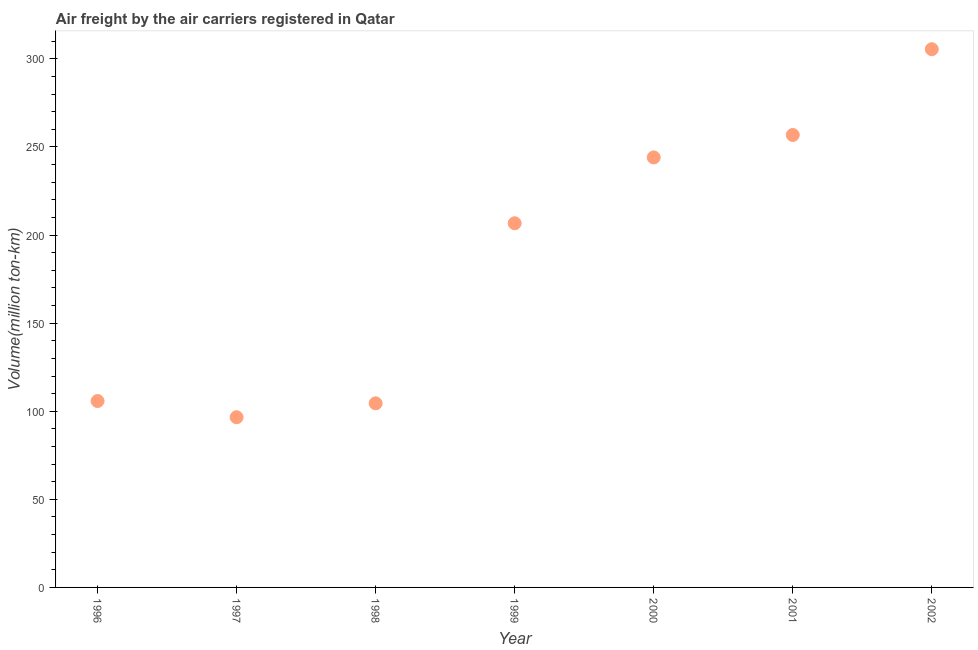What is the air freight in 1999?
Your answer should be very brief. 206.7. Across all years, what is the maximum air freight?
Make the answer very short. 305.48. Across all years, what is the minimum air freight?
Ensure brevity in your answer.  96.6. In which year was the air freight minimum?
Offer a very short reply. 1997. What is the sum of the air freight?
Offer a terse response. 1319.97. What is the difference between the air freight in 1998 and 2002?
Your response must be concise. -200.98. What is the average air freight per year?
Ensure brevity in your answer.  188.57. What is the median air freight?
Provide a succinct answer. 206.7. Do a majority of the years between 2001 and 1996 (inclusive) have air freight greater than 280 million ton-km?
Provide a short and direct response. Yes. What is the ratio of the air freight in 1997 to that in 2002?
Offer a very short reply. 0.32. What is the difference between the highest and the second highest air freight?
Offer a terse response. 48.67. What is the difference between the highest and the lowest air freight?
Provide a short and direct response. 208.88. How many dotlines are there?
Your answer should be very brief. 1. Are the values on the major ticks of Y-axis written in scientific E-notation?
Give a very brief answer. No. Does the graph contain any zero values?
Offer a terse response. No. What is the title of the graph?
Your answer should be very brief. Air freight by the air carriers registered in Qatar. What is the label or title of the Y-axis?
Provide a succinct answer. Volume(million ton-km). What is the Volume(million ton-km) in 1996?
Your response must be concise. 105.8. What is the Volume(million ton-km) in 1997?
Provide a short and direct response. 96.6. What is the Volume(million ton-km) in 1998?
Your response must be concise. 104.5. What is the Volume(million ton-km) in 1999?
Provide a short and direct response. 206.7. What is the Volume(million ton-km) in 2000?
Offer a very short reply. 244.07. What is the Volume(million ton-km) in 2001?
Provide a succinct answer. 256.82. What is the Volume(million ton-km) in 2002?
Offer a very short reply. 305.48. What is the difference between the Volume(million ton-km) in 1996 and 1998?
Offer a very short reply. 1.3. What is the difference between the Volume(million ton-km) in 1996 and 1999?
Ensure brevity in your answer.  -100.9. What is the difference between the Volume(million ton-km) in 1996 and 2000?
Your response must be concise. -138.27. What is the difference between the Volume(million ton-km) in 1996 and 2001?
Offer a terse response. -151.02. What is the difference between the Volume(million ton-km) in 1996 and 2002?
Ensure brevity in your answer.  -199.68. What is the difference between the Volume(million ton-km) in 1997 and 1999?
Keep it short and to the point. -110.1. What is the difference between the Volume(million ton-km) in 1997 and 2000?
Offer a very short reply. -147.47. What is the difference between the Volume(million ton-km) in 1997 and 2001?
Offer a terse response. -160.22. What is the difference between the Volume(million ton-km) in 1997 and 2002?
Provide a short and direct response. -208.88. What is the difference between the Volume(million ton-km) in 1998 and 1999?
Your answer should be compact. -102.2. What is the difference between the Volume(million ton-km) in 1998 and 2000?
Ensure brevity in your answer.  -139.57. What is the difference between the Volume(million ton-km) in 1998 and 2001?
Give a very brief answer. -152.32. What is the difference between the Volume(million ton-km) in 1998 and 2002?
Keep it short and to the point. -200.98. What is the difference between the Volume(million ton-km) in 1999 and 2000?
Your response must be concise. -37.37. What is the difference between the Volume(million ton-km) in 1999 and 2001?
Ensure brevity in your answer.  -50.12. What is the difference between the Volume(million ton-km) in 1999 and 2002?
Offer a terse response. -98.78. What is the difference between the Volume(million ton-km) in 2000 and 2001?
Your response must be concise. -12.75. What is the difference between the Volume(million ton-km) in 2000 and 2002?
Offer a very short reply. -61.41. What is the difference between the Volume(million ton-km) in 2001 and 2002?
Your response must be concise. -48.67. What is the ratio of the Volume(million ton-km) in 1996 to that in 1997?
Keep it short and to the point. 1.09. What is the ratio of the Volume(million ton-km) in 1996 to that in 1998?
Offer a very short reply. 1.01. What is the ratio of the Volume(million ton-km) in 1996 to that in 1999?
Offer a very short reply. 0.51. What is the ratio of the Volume(million ton-km) in 1996 to that in 2000?
Your response must be concise. 0.43. What is the ratio of the Volume(million ton-km) in 1996 to that in 2001?
Give a very brief answer. 0.41. What is the ratio of the Volume(million ton-km) in 1996 to that in 2002?
Offer a very short reply. 0.35. What is the ratio of the Volume(million ton-km) in 1997 to that in 1998?
Provide a short and direct response. 0.92. What is the ratio of the Volume(million ton-km) in 1997 to that in 1999?
Your answer should be compact. 0.47. What is the ratio of the Volume(million ton-km) in 1997 to that in 2000?
Make the answer very short. 0.4. What is the ratio of the Volume(million ton-km) in 1997 to that in 2001?
Your answer should be very brief. 0.38. What is the ratio of the Volume(million ton-km) in 1997 to that in 2002?
Your answer should be compact. 0.32. What is the ratio of the Volume(million ton-km) in 1998 to that in 1999?
Your answer should be compact. 0.51. What is the ratio of the Volume(million ton-km) in 1998 to that in 2000?
Make the answer very short. 0.43. What is the ratio of the Volume(million ton-km) in 1998 to that in 2001?
Provide a short and direct response. 0.41. What is the ratio of the Volume(million ton-km) in 1998 to that in 2002?
Your answer should be very brief. 0.34. What is the ratio of the Volume(million ton-km) in 1999 to that in 2000?
Offer a terse response. 0.85. What is the ratio of the Volume(million ton-km) in 1999 to that in 2001?
Your answer should be compact. 0.81. What is the ratio of the Volume(million ton-km) in 1999 to that in 2002?
Give a very brief answer. 0.68. What is the ratio of the Volume(million ton-km) in 2000 to that in 2002?
Your response must be concise. 0.8. What is the ratio of the Volume(million ton-km) in 2001 to that in 2002?
Provide a succinct answer. 0.84. 